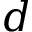Convert formula to latex. <formula><loc_0><loc_0><loc_500><loc_500>{ d }</formula> 